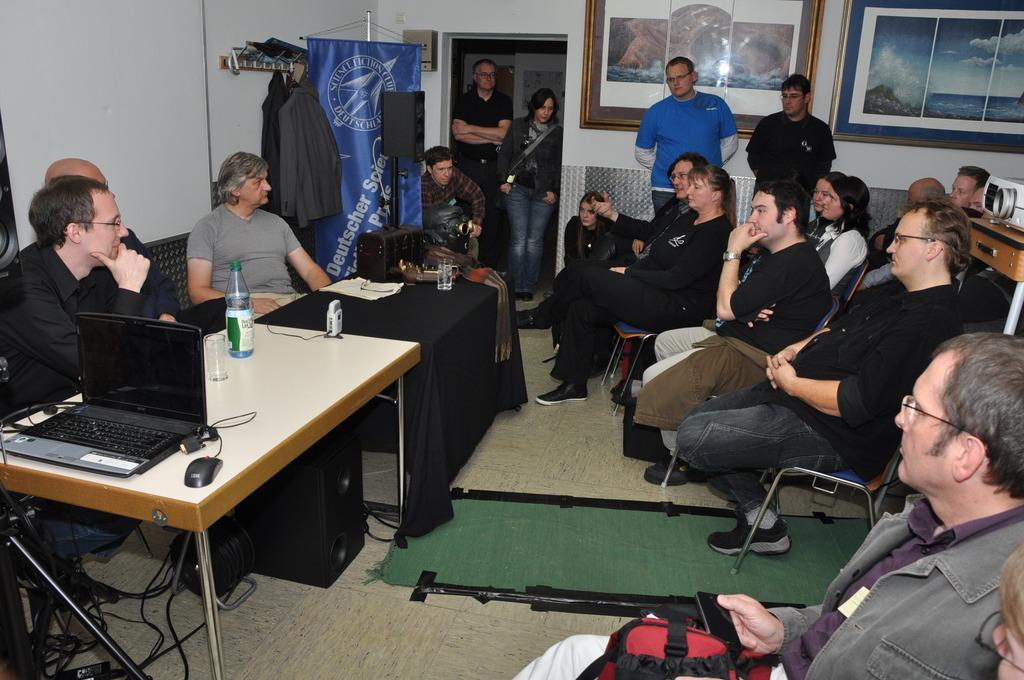How would you summarize this image in a sentence or two? In this image I can see people where few of them are standing and rest all are sitting on chairs. Here on this table I can see a bottle, few glasses, a laptop and a mouse. In the background I can see few frames on this wall and few clothes. 